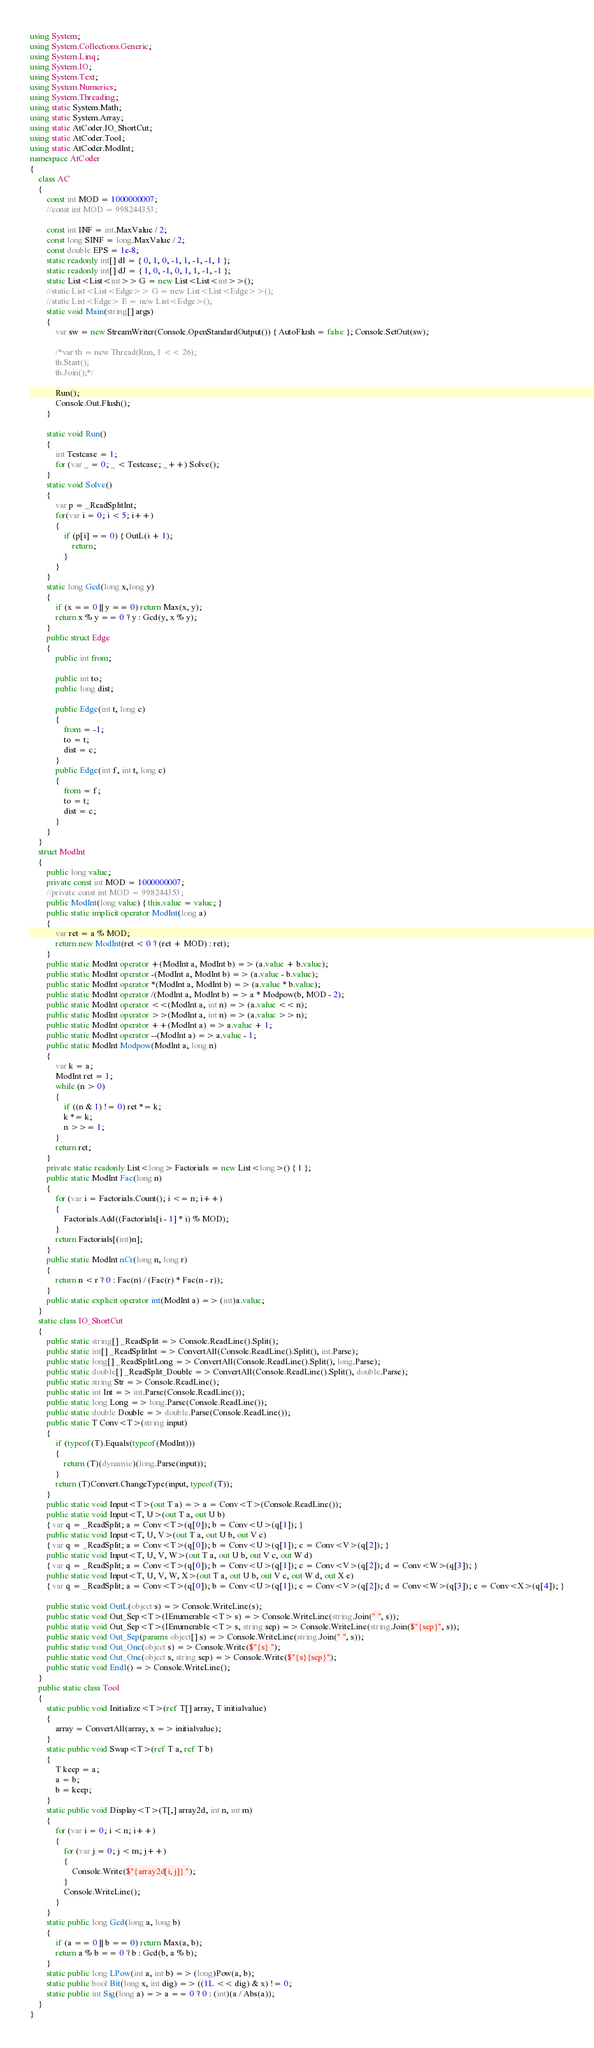<code> <loc_0><loc_0><loc_500><loc_500><_C#_>using System;
using System.Collections.Generic;
using System.Linq;
using System.IO;
using System.Text;
using System.Numerics;
using System.Threading;
using static System.Math;
using static System.Array;
using static AtCoder.IO_ShortCut;
using static AtCoder.Tool;
using static AtCoder.ModInt;
namespace AtCoder
{
    class AC
    {
        const int MOD = 1000000007;
        //const int MOD = 998244353;

        const int INF = int.MaxValue / 2;
        const long SINF = long.MaxValue / 2;
        const double EPS = 1e-8;
        static readonly int[] dI = { 0, 1, 0, -1, 1, -1, -1, 1 };
        static readonly int[] dJ = { 1, 0, -1, 0, 1, 1, -1, -1 };
        static List<List<int>> G = new List<List<int>>();
        //static List<List<Edge>> G = new List<List<Edge>>();
        //static List<Edge> E = new List<Edge>();
        static void Main(string[] args)
        {
            var sw = new StreamWriter(Console.OpenStandardOutput()) { AutoFlush = false }; Console.SetOut(sw);

            /*var th = new Thread(Run, 1 << 26);
            th.Start();
            th.Join();*/

            Run();
            Console.Out.Flush();
        }

        static void Run()
        {
            int Testcase = 1;
            for (var _ = 0; _ < Testcase; _++) Solve();
        }
        static void Solve()
        {
            var p = _ReadSplitInt;
            for(var i = 0; i < 5; i++)
            {
                if (p[i] == 0) { OutL(i + 1);
                    return;
                }
            }
        }
        static long Gcd(long x,long y)
        {
            if (x == 0 || y == 0) return Max(x, y);
            return x % y == 0 ? y : Gcd(y, x % y);
        }
        public struct Edge
        {
            public int from;

            public int to;
            public long dist;

            public Edge(int t, long c)
            {
                from = -1;
                to = t;
                dist = c;
            }
            public Edge(int f, int t, long c)
            {
                from = f;
                to = t;
                dist = c;
            }
        }
    }
    struct ModInt
    {
        public long value;
        private const int MOD = 1000000007;
        //private const int MOD = 998244353;
        public ModInt(long value) { this.value = value; }
        public static implicit operator ModInt(long a)
        {
            var ret = a % MOD;
            return new ModInt(ret < 0 ? (ret + MOD) : ret);
        }
        public static ModInt operator +(ModInt a, ModInt b) => (a.value + b.value);
        public static ModInt operator -(ModInt a, ModInt b) => (a.value - b.value);
        public static ModInt operator *(ModInt a, ModInt b) => (a.value * b.value);
        public static ModInt operator /(ModInt a, ModInt b) => a * Modpow(b, MOD - 2);
        public static ModInt operator <<(ModInt a, int n) => (a.value << n);
        public static ModInt operator >>(ModInt a, int n) => (a.value >> n);
        public static ModInt operator ++(ModInt a) => a.value + 1;
        public static ModInt operator --(ModInt a) => a.value - 1;
        public static ModInt Modpow(ModInt a, long n)
        {
            var k = a;
            ModInt ret = 1;
            while (n > 0)
            {
                if ((n & 1) != 0) ret *= k;
                k *= k;
                n >>= 1;
            }
            return ret;
        }
        private static readonly List<long> Factorials = new List<long>() { 1 };
        public static ModInt Fac(long n)
        {
            for (var i = Factorials.Count(); i <= n; i++)
            {
                Factorials.Add((Factorials[i - 1] * i) % MOD);
            }
            return Factorials[(int)n];
        }
        public static ModInt nCr(long n, long r)
        {
            return n < r ? 0 : Fac(n) / (Fac(r) * Fac(n - r));
        }
        public static explicit operator int(ModInt a) => (int)a.value;
    }
    static class IO_ShortCut
    {
        public static string[] _ReadSplit => Console.ReadLine().Split();
        public static int[] _ReadSplitInt => ConvertAll(Console.ReadLine().Split(), int.Parse);
        public static long[] _ReadSplitLong => ConvertAll(Console.ReadLine().Split(), long.Parse);
        public static double[] _ReadSplit_Double => ConvertAll(Console.ReadLine().Split(), double.Parse);
        public static string Str => Console.ReadLine();
        public static int Int => int.Parse(Console.ReadLine());
        public static long Long => long.Parse(Console.ReadLine());
        public static double Double => double.Parse(Console.ReadLine());
        public static T Conv<T>(string input)
        {
            if (typeof(T).Equals(typeof(ModInt)))
            {
                return (T)(dynamic)(long.Parse(input));
            }
            return (T)Convert.ChangeType(input, typeof(T));
        }
        public static void Input<T>(out T a) => a = Conv<T>(Console.ReadLine());
        public static void Input<T, U>(out T a, out U b)
        { var q = _ReadSplit; a = Conv<T>(q[0]); b = Conv<U>(q[1]); }
        public static void Input<T, U, V>(out T a, out U b, out V c)
        { var q = _ReadSplit; a = Conv<T>(q[0]); b = Conv<U>(q[1]); c = Conv<V>(q[2]); }
        public static void Input<T, U, V, W>(out T a, out U b, out V c, out W d)
        { var q = _ReadSplit; a = Conv<T>(q[0]); b = Conv<U>(q[1]); c = Conv<V>(q[2]); d = Conv<W>(q[3]); }
        public static void Input<T, U, V, W, X>(out T a, out U b, out V c, out W d, out X e)
        { var q = _ReadSplit; a = Conv<T>(q[0]); b = Conv<U>(q[1]); c = Conv<V>(q[2]); d = Conv<W>(q[3]); e = Conv<X>(q[4]); }

        public static void OutL(object s) => Console.WriteLine(s);
        public static void Out_Sep<T>(IEnumerable<T> s) => Console.WriteLine(string.Join(" ", s));
        public static void Out_Sep<T>(IEnumerable<T> s, string sep) => Console.WriteLine(string.Join($"{sep}", s));
        public static void Out_Sep(params object[] s) => Console.WriteLine(string.Join(" ", s));
        public static void Out_One(object s) => Console.Write($"{s} ");
        public static void Out_One(object s, string sep) => Console.Write($"{s}{sep}");
        public static void Endl() => Console.WriteLine();
    }
    public static class Tool
    {
        static public void Initialize<T>(ref T[] array, T initialvalue)
        {
            array = ConvertAll(array, x => initialvalue);
        }
        static public void Swap<T>(ref T a, ref T b)
        {
            T keep = a;
            a = b;
            b = keep;
        }
        static public void Display<T>(T[,] array2d, int n, int m)
        {
            for (var i = 0; i < n; i++)
            {
                for (var j = 0; j < m; j++)
                {
                    Console.Write($"{array2d[i, j]} ");
                }
                Console.WriteLine();
            }
        }
        static public long Gcd(long a, long b)
        {
            if (a == 0 || b == 0) return Max(a, b);
            return a % b == 0 ? b : Gcd(b, a % b);
        }
        static public long LPow(int a, int b) => (long)Pow(a, b);
        static public bool Bit(long x, int dig) => ((1L << dig) & x) != 0;
        static public int Sig(long a) => a == 0 ? 0 : (int)(a / Abs(a));
    }
}
</code> 